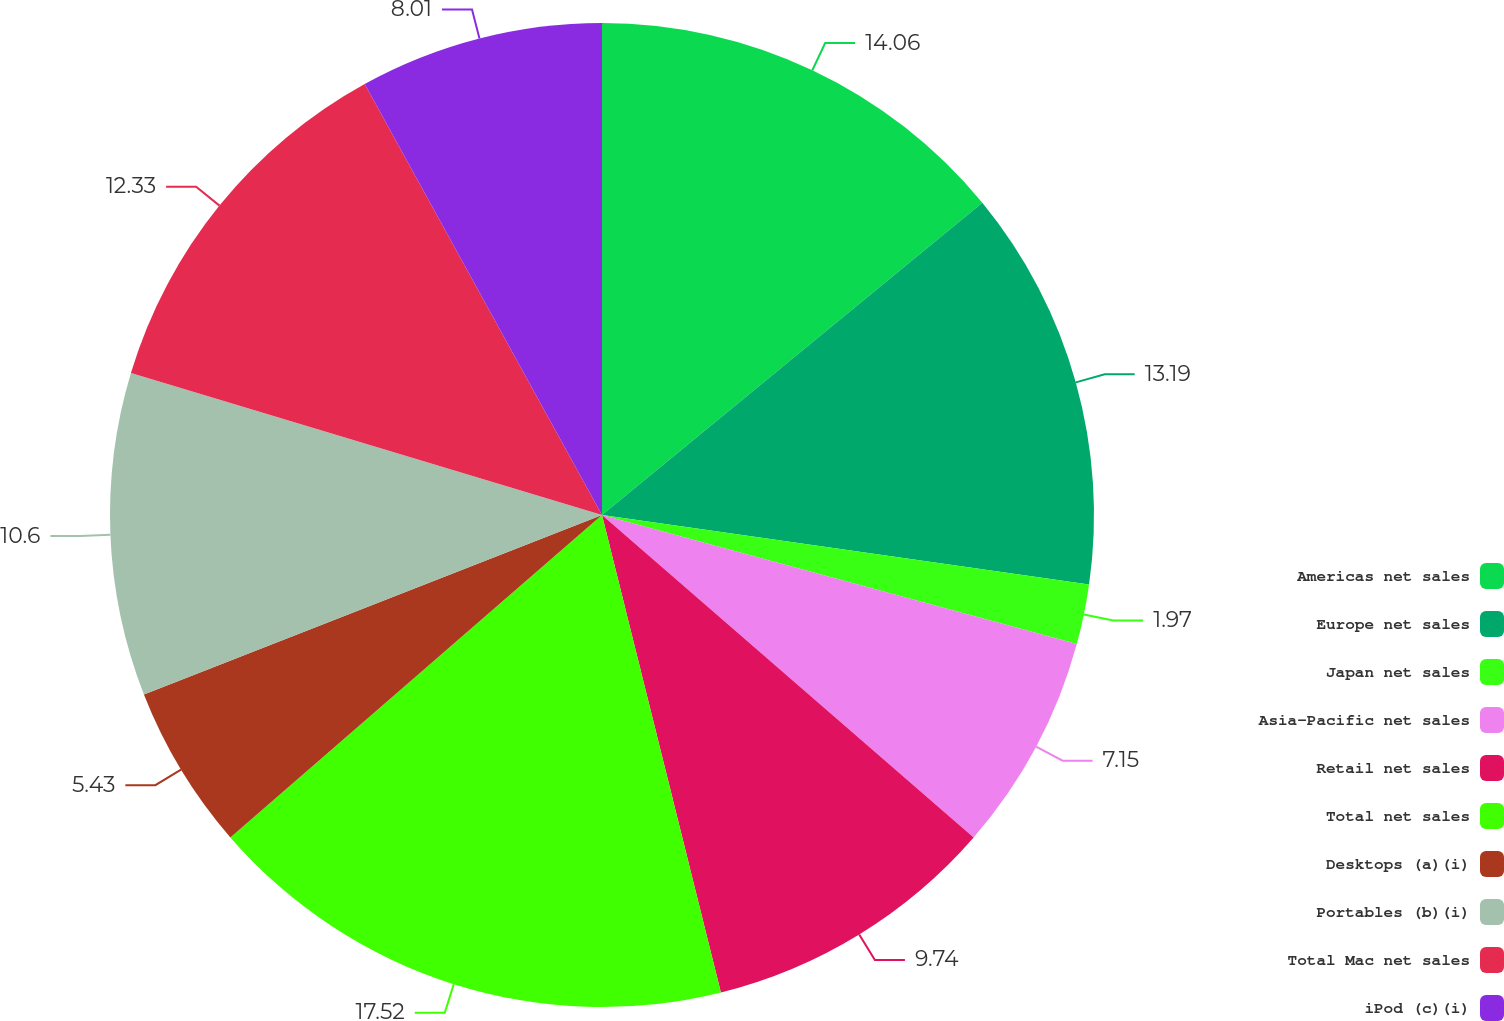Convert chart to OTSL. <chart><loc_0><loc_0><loc_500><loc_500><pie_chart><fcel>Americas net sales<fcel>Europe net sales<fcel>Japan net sales<fcel>Asia-Pacific net sales<fcel>Retail net sales<fcel>Total net sales<fcel>Desktops (a)(i)<fcel>Portables (b)(i)<fcel>Total Mac net sales<fcel>iPod (c)(i)<nl><fcel>14.06%<fcel>13.19%<fcel>1.97%<fcel>7.15%<fcel>9.74%<fcel>17.51%<fcel>5.43%<fcel>10.6%<fcel>12.33%<fcel>8.01%<nl></chart> 